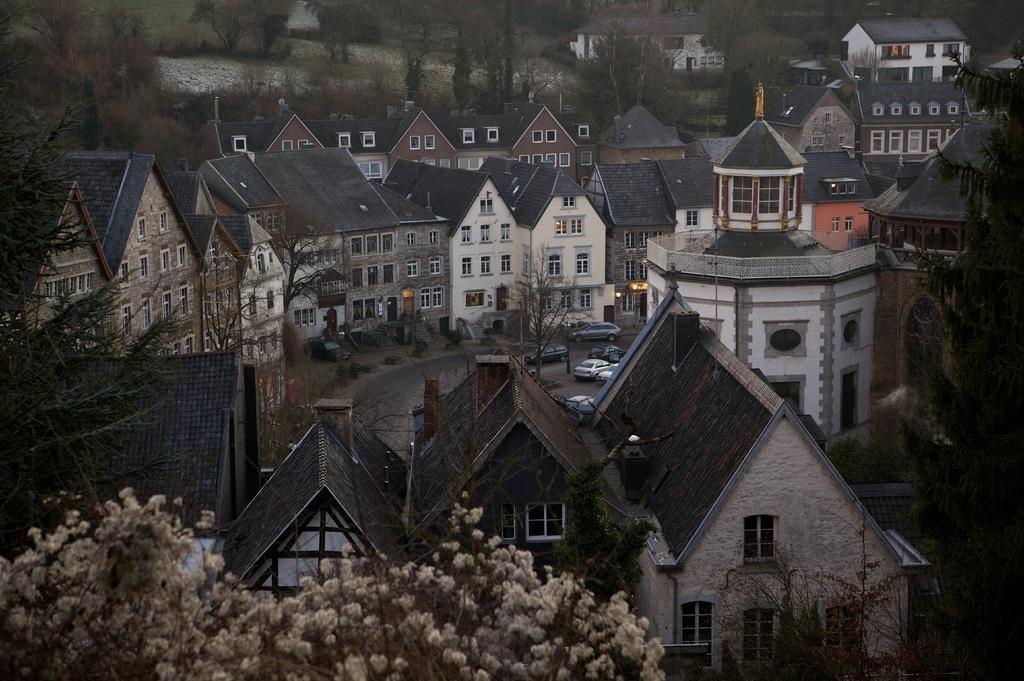Could you give a brief overview of what you see in this image? In this image there are trees, houses and there are cars on road. 